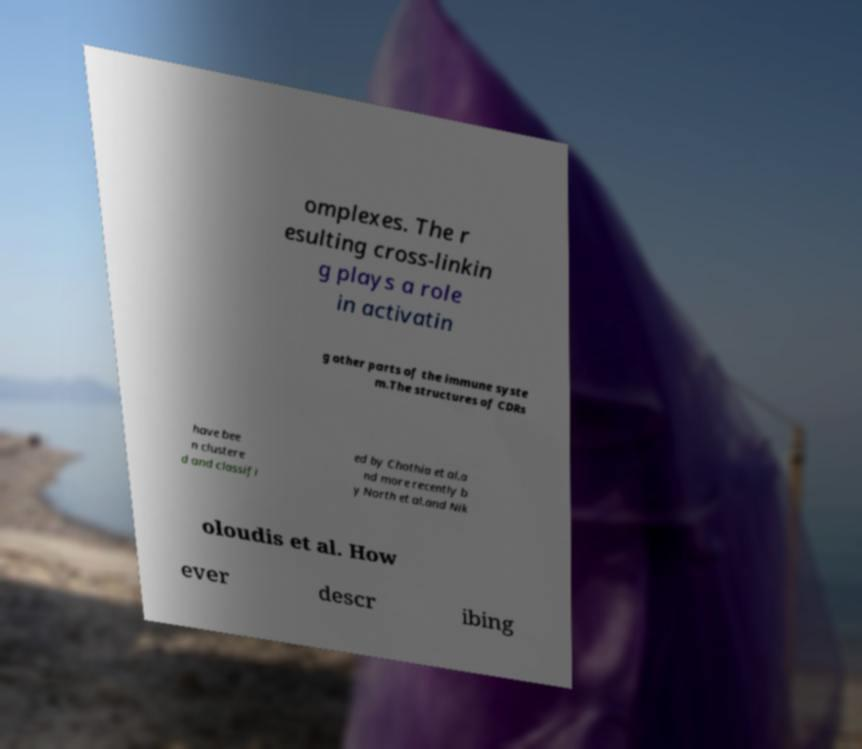Could you assist in decoding the text presented in this image and type it out clearly? omplexes. The r esulting cross-linkin g plays a role in activatin g other parts of the immune syste m.The structures of CDRs have bee n clustere d and classifi ed by Chothia et al.a nd more recently b y North et al.and Nik oloudis et al. How ever descr ibing 